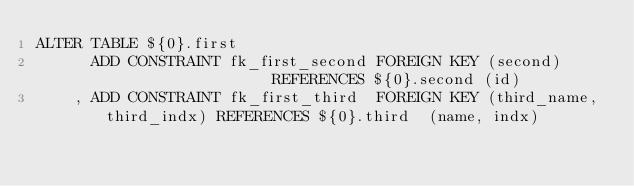<code> <loc_0><loc_0><loc_500><loc_500><_SQL_>ALTER TABLE ${0}.first
      ADD CONSTRAINT fk_first_second FOREIGN KEY (second)                 REFERENCES ${0}.second (id)
    , ADD CONSTRAINT fk_first_third  FOREIGN KEY (third_name, third_indx) REFERENCES ${0}.third  (name, indx)</code> 